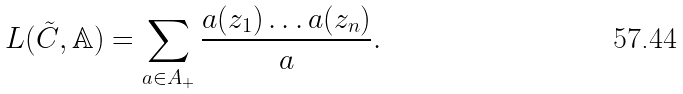<formula> <loc_0><loc_0><loc_500><loc_500>L ( \tilde { C } , \mathbb { A } ) = \sum _ { a \in A _ { + } } \frac { a ( z _ { 1 } ) \dots a ( z _ { n } ) } { a } .</formula> 